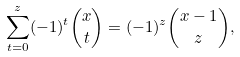<formula> <loc_0><loc_0><loc_500><loc_500>\sum _ { t = 0 } ^ { z } ( - 1 ) ^ { t } \binom { x } { t } = ( - 1 ) ^ { z } \binom { x - 1 } { z } ,</formula> 